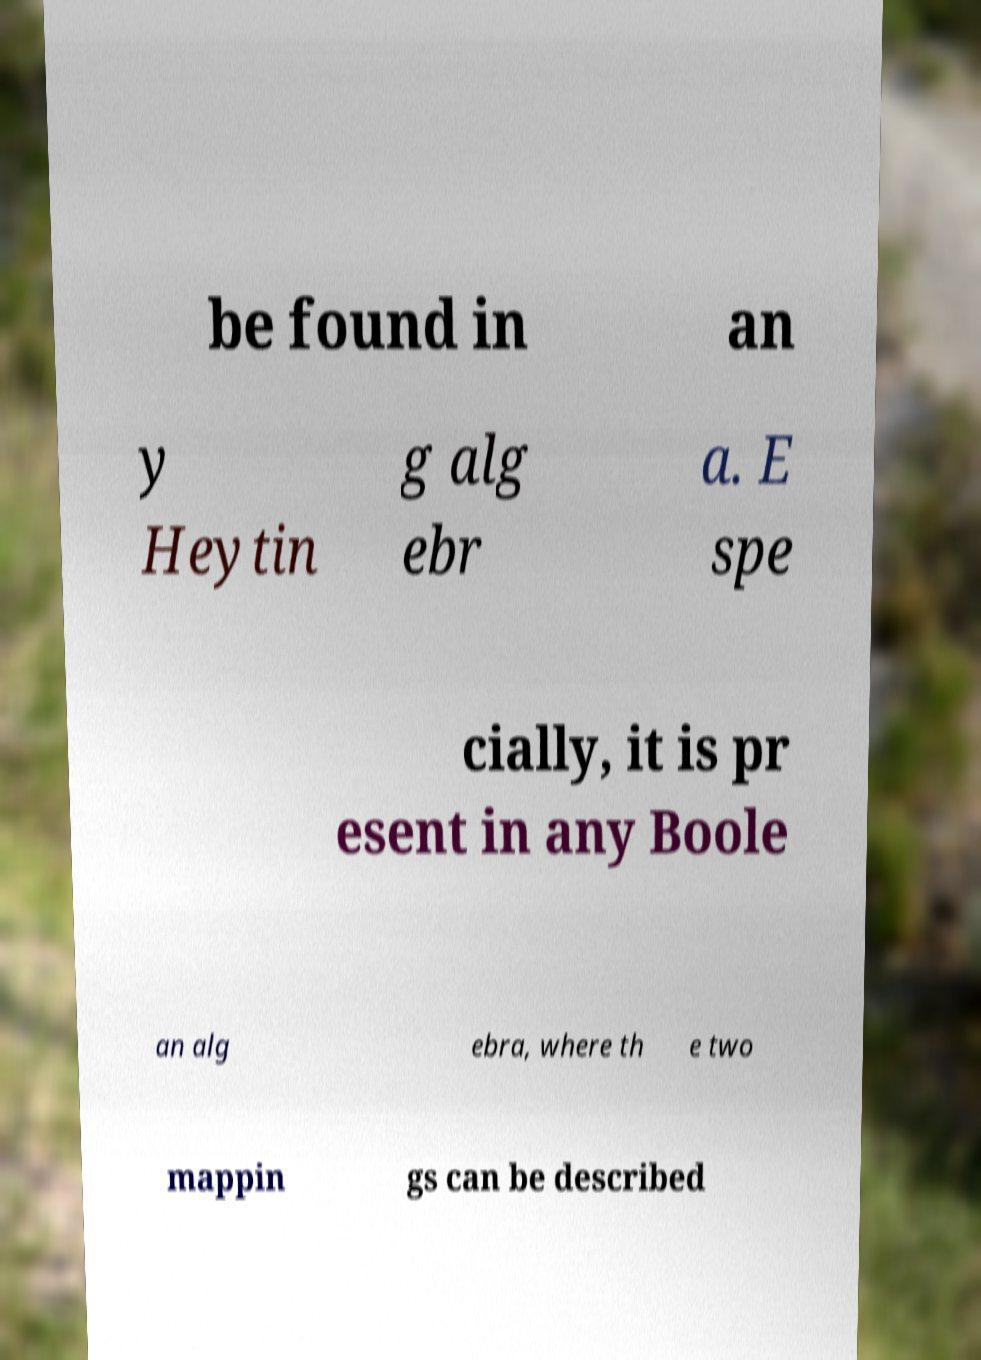Please identify and transcribe the text found in this image. be found in an y Heytin g alg ebr a. E spe cially, it is pr esent in any Boole an alg ebra, where th e two mappin gs can be described 